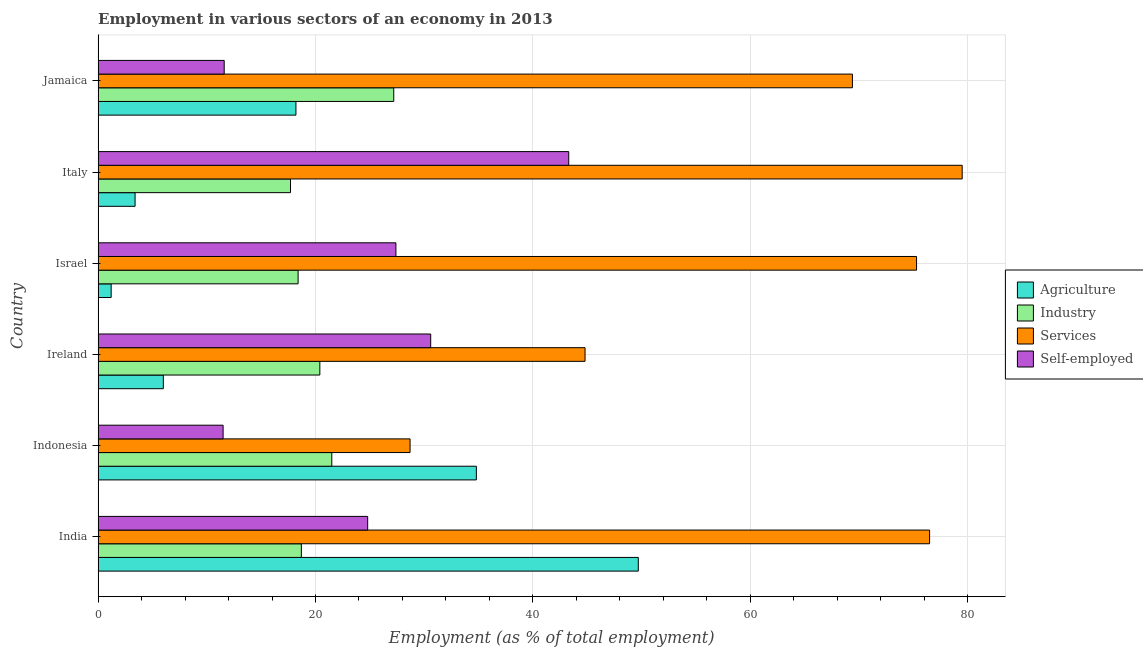How many different coloured bars are there?
Give a very brief answer. 4. How many groups of bars are there?
Your answer should be compact. 6. Are the number of bars per tick equal to the number of legend labels?
Provide a short and direct response. Yes. Are the number of bars on each tick of the Y-axis equal?
Give a very brief answer. Yes. How many bars are there on the 2nd tick from the bottom?
Provide a succinct answer. 4. What is the label of the 6th group of bars from the top?
Your answer should be compact. India. In how many cases, is the number of bars for a given country not equal to the number of legend labels?
Make the answer very short. 0. What is the percentage of workers in services in Jamaica?
Provide a succinct answer. 69.4. Across all countries, what is the maximum percentage of workers in services?
Your answer should be compact. 79.5. Across all countries, what is the minimum percentage of workers in industry?
Offer a very short reply. 17.7. What is the total percentage of self employed workers in the graph?
Provide a short and direct response. 149.2. What is the difference between the percentage of workers in agriculture in India and that in Ireland?
Provide a short and direct response. 43.7. What is the difference between the percentage of workers in industry in Jamaica and the percentage of workers in agriculture in Indonesia?
Make the answer very short. -7.6. What is the average percentage of workers in industry per country?
Provide a succinct answer. 20.65. In how many countries, is the percentage of workers in services greater than 76 %?
Your answer should be compact. 2. What is the ratio of the percentage of workers in services in Israel to that in Jamaica?
Offer a terse response. 1.08. Is the difference between the percentage of workers in services in India and Israel greater than the difference between the percentage of self employed workers in India and Israel?
Your response must be concise. Yes. What is the difference between the highest and the second highest percentage of workers in agriculture?
Keep it short and to the point. 14.9. What is the difference between the highest and the lowest percentage of workers in agriculture?
Your response must be concise. 48.5. In how many countries, is the percentage of self employed workers greater than the average percentage of self employed workers taken over all countries?
Provide a succinct answer. 3. Is the sum of the percentage of workers in services in Indonesia and Jamaica greater than the maximum percentage of workers in industry across all countries?
Keep it short and to the point. Yes. Is it the case that in every country, the sum of the percentage of workers in industry and percentage of workers in services is greater than the sum of percentage of self employed workers and percentage of workers in agriculture?
Your answer should be very brief. No. What does the 2nd bar from the top in Italy represents?
Provide a succinct answer. Services. What does the 2nd bar from the bottom in Jamaica represents?
Provide a succinct answer. Industry. Is it the case that in every country, the sum of the percentage of workers in agriculture and percentage of workers in industry is greater than the percentage of workers in services?
Your answer should be compact. No. How many bars are there?
Make the answer very short. 24. How many countries are there in the graph?
Offer a terse response. 6. What is the difference between two consecutive major ticks on the X-axis?
Ensure brevity in your answer.  20. How many legend labels are there?
Your answer should be very brief. 4. What is the title of the graph?
Offer a terse response. Employment in various sectors of an economy in 2013. Does "Ease of arranging shipments" appear as one of the legend labels in the graph?
Give a very brief answer. No. What is the label or title of the X-axis?
Ensure brevity in your answer.  Employment (as % of total employment). What is the Employment (as % of total employment) in Agriculture in India?
Keep it short and to the point. 49.7. What is the Employment (as % of total employment) of Industry in India?
Your answer should be compact. 18.7. What is the Employment (as % of total employment) of Services in India?
Keep it short and to the point. 76.5. What is the Employment (as % of total employment) in Self-employed in India?
Make the answer very short. 24.8. What is the Employment (as % of total employment) of Agriculture in Indonesia?
Provide a short and direct response. 34.8. What is the Employment (as % of total employment) in Services in Indonesia?
Give a very brief answer. 28.7. What is the Employment (as % of total employment) of Industry in Ireland?
Your answer should be compact. 20.4. What is the Employment (as % of total employment) of Services in Ireland?
Your answer should be very brief. 44.8. What is the Employment (as % of total employment) in Self-employed in Ireland?
Your answer should be compact. 30.6. What is the Employment (as % of total employment) in Agriculture in Israel?
Give a very brief answer. 1.2. What is the Employment (as % of total employment) in Industry in Israel?
Your answer should be compact. 18.4. What is the Employment (as % of total employment) in Services in Israel?
Make the answer very short. 75.3. What is the Employment (as % of total employment) in Self-employed in Israel?
Give a very brief answer. 27.4. What is the Employment (as % of total employment) in Agriculture in Italy?
Your answer should be very brief. 3.4. What is the Employment (as % of total employment) of Industry in Italy?
Ensure brevity in your answer.  17.7. What is the Employment (as % of total employment) in Services in Italy?
Offer a terse response. 79.5. What is the Employment (as % of total employment) in Self-employed in Italy?
Keep it short and to the point. 43.3. What is the Employment (as % of total employment) of Agriculture in Jamaica?
Ensure brevity in your answer.  18.2. What is the Employment (as % of total employment) of Industry in Jamaica?
Provide a succinct answer. 27.2. What is the Employment (as % of total employment) in Services in Jamaica?
Ensure brevity in your answer.  69.4. What is the Employment (as % of total employment) of Self-employed in Jamaica?
Your answer should be compact. 11.6. Across all countries, what is the maximum Employment (as % of total employment) of Agriculture?
Make the answer very short. 49.7. Across all countries, what is the maximum Employment (as % of total employment) in Industry?
Offer a very short reply. 27.2. Across all countries, what is the maximum Employment (as % of total employment) of Services?
Your answer should be compact. 79.5. Across all countries, what is the maximum Employment (as % of total employment) in Self-employed?
Offer a terse response. 43.3. Across all countries, what is the minimum Employment (as % of total employment) of Agriculture?
Provide a short and direct response. 1.2. Across all countries, what is the minimum Employment (as % of total employment) in Industry?
Give a very brief answer. 17.7. Across all countries, what is the minimum Employment (as % of total employment) in Services?
Your response must be concise. 28.7. What is the total Employment (as % of total employment) in Agriculture in the graph?
Keep it short and to the point. 113.3. What is the total Employment (as % of total employment) of Industry in the graph?
Your response must be concise. 123.9. What is the total Employment (as % of total employment) in Services in the graph?
Offer a very short reply. 374.2. What is the total Employment (as % of total employment) in Self-employed in the graph?
Give a very brief answer. 149.2. What is the difference between the Employment (as % of total employment) in Agriculture in India and that in Indonesia?
Your response must be concise. 14.9. What is the difference between the Employment (as % of total employment) of Services in India and that in Indonesia?
Offer a terse response. 47.8. What is the difference between the Employment (as % of total employment) in Agriculture in India and that in Ireland?
Your answer should be compact. 43.7. What is the difference between the Employment (as % of total employment) of Industry in India and that in Ireland?
Provide a short and direct response. -1.7. What is the difference between the Employment (as % of total employment) in Services in India and that in Ireland?
Your answer should be compact. 31.7. What is the difference between the Employment (as % of total employment) in Self-employed in India and that in Ireland?
Ensure brevity in your answer.  -5.8. What is the difference between the Employment (as % of total employment) of Agriculture in India and that in Israel?
Your response must be concise. 48.5. What is the difference between the Employment (as % of total employment) in Agriculture in India and that in Italy?
Offer a very short reply. 46.3. What is the difference between the Employment (as % of total employment) of Self-employed in India and that in Italy?
Ensure brevity in your answer.  -18.5. What is the difference between the Employment (as % of total employment) in Agriculture in India and that in Jamaica?
Offer a terse response. 31.5. What is the difference between the Employment (as % of total employment) of Services in India and that in Jamaica?
Provide a short and direct response. 7.1. What is the difference between the Employment (as % of total employment) in Self-employed in India and that in Jamaica?
Offer a terse response. 13.2. What is the difference between the Employment (as % of total employment) in Agriculture in Indonesia and that in Ireland?
Provide a short and direct response. 28.8. What is the difference between the Employment (as % of total employment) of Industry in Indonesia and that in Ireland?
Keep it short and to the point. 1.1. What is the difference between the Employment (as % of total employment) of Services in Indonesia and that in Ireland?
Ensure brevity in your answer.  -16.1. What is the difference between the Employment (as % of total employment) in Self-employed in Indonesia and that in Ireland?
Your response must be concise. -19.1. What is the difference between the Employment (as % of total employment) of Agriculture in Indonesia and that in Israel?
Your answer should be compact. 33.6. What is the difference between the Employment (as % of total employment) of Industry in Indonesia and that in Israel?
Your response must be concise. 3.1. What is the difference between the Employment (as % of total employment) of Services in Indonesia and that in Israel?
Offer a very short reply. -46.6. What is the difference between the Employment (as % of total employment) in Self-employed in Indonesia and that in Israel?
Give a very brief answer. -15.9. What is the difference between the Employment (as % of total employment) in Agriculture in Indonesia and that in Italy?
Offer a terse response. 31.4. What is the difference between the Employment (as % of total employment) in Services in Indonesia and that in Italy?
Offer a terse response. -50.8. What is the difference between the Employment (as % of total employment) of Self-employed in Indonesia and that in Italy?
Offer a terse response. -31.8. What is the difference between the Employment (as % of total employment) in Agriculture in Indonesia and that in Jamaica?
Keep it short and to the point. 16.6. What is the difference between the Employment (as % of total employment) of Services in Indonesia and that in Jamaica?
Your answer should be very brief. -40.7. What is the difference between the Employment (as % of total employment) in Agriculture in Ireland and that in Israel?
Ensure brevity in your answer.  4.8. What is the difference between the Employment (as % of total employment) in Industry in Ireland and that in Israel?
Your answer should be compact. 2. What is the difference between the Employment (as % of total employment) of Services in Ireland and that in Israel?
Offer a very short reply. -30.5. What is the difference between the Employment (as % of total employment) of Self-employed in Ireland and that in Israel?
Offer a terse response. 3.2. What is the difference between the Employment (as % of total employment) in Agriculture in Ireland and that in Italy?
Your answer should be compact. 2.6. What is the difference between the Employment (as % of total employment) in Industry in Ireland and that in Italy?
Offer a very short reply. 2.7. What is the difference between the Employment (as % of total employment) in Services in Ireland and that in Italy?
Provide a short and direct response. -34.7. What is the difference between the Employment (as % of total employment) in Self-employed in Ireland and that in Italy?
Provide a short and direct response. -12.7. What is the difference between the Employment (as % of total employment) in Agriculture in Ireland and that in Jamaica?
Provide a short and direct response. -12.2. What is the difference between the Employment (as % of total employment) of Industry in Ireland and that in Jamaica?
Your response must be concise. -6.8. What is the difference between the Employment (as % of total employment) in Services in Ireland and that in Jamaica?
Your answer should be compact. -24.6. What is the difference between the Employment (as % of total employment) of Agriculture in Israel and that in Italy?
Make the answer very short. -2.2. What is the difference between the Employment (as % of total employment) of Industry in Israel and that in Italy?
Provide a short and direct response. 0.7. What is the difference between the Employment (as % of total employment) of Self-employed in Israel and that in Italy?
Your response must be concise. -15.9. What is the difference between the Employment (as % of total employment) in Agriculture in Israel and that in Jamaica?
Your answer should be compact. -17. What is the difference between the Employment (as % of total employment) of Industry in Israel and that in Jamaica?
Your answer should be very brief. -8.8. What is the difference between the Employment (as % of total employment) in Services in Israel and that in Jamaica?
Provide a succinct answer. 5.9. What is the difference between the Employment (as % of total employment) of Self-employed in Israel and that in Jamaica?
Offer a terse response. 15.8. What is the difference between the Employment (as % of total employment) in Agriculture in Italy and that in Jamaica?
Make the answer very short. -14.8. What is the difference between the Employment (as % of total employment) in Industry in Italy and that in Jamaica?
Provide a succinct answer. -9.5. What is the difference between the Employment (as % of total employment) of Services in Italy and that in Jamaica?
Give a very brief answer. 10.1. What is the difference between the Employment (as % of total employment) in Self-employed in Italy and that in Jamaica?
Keep it short and to the point. 31.7. What is the difference between the Employment (as % of total employment) in Agriculture in India and the Employment (as % of total employment) in Industry in Indonesia?
Your answer should be very brief. 28.2. What is the difference between the Employment (as % of total employment) in Agriculture in India and the Employment (as % of total employment) in Services in Indonesia?
Provide a short and direct response. 21. What is the difference between the Employment (as % of total employment) of Agriculture in India and the Employment (as % of total employment) of Self-employed in Indonesia?
Keep it short and to the point. 38.2. What is the difference between the Employment (as % of total employment) of Industry in India and the Employment (as % of total employment) of Self-employed in Indonesia?
Your answer should be very brief. 7.2. What is the difference between the Employment (as % of total employment) in Agriculture in India and the Employment (as % of total employment) in Industry in Ireland?
Your answer should be compact. 29.3. What is the difference between the Employment (as % of total employment) in Agriculture in India and the Employment (as % of total employment) in Services in Ireland?
Offer a very short reply. 4.9. What is the difference between the Employment (as % of total employment) in Industry in India and the Employment (as % of total employment) in Services in Ireland?
Offer a very short reply. -26.1. What is the difference between the Employment (as % of total employment) of Industry in India and the Employment (as % of total employment) of Self-employed in Ireland?
Your response must be concise. -11.9. What is the difference between the Employment (as % of total employment) of Services in India and the Employment (as % of total employment) of Self-employed in Ireland?
Provide a succinct answer. 45.9. What is the difference between the Employment (as % of total employment) in Agriculture in India and the Employment (as % of total employment) in Industry in Israel?
Ensure brevity in your answer.  31.3. What is the difference between the Employment (as % of total employment) in Agriculture in India and the Employment (as % of total employment) in Services in Israel?
Ensure brevity in your answer.  -25.6. What is the difference between the Employment (as % of total employment) in Agriculture in India and the Employment (as % of total employment) in Self-employed in Israel?
Your answer should be compact. 22.3. What is the difference between the Employment (as % of total employment) of Industry in India and the Employment (as % of total employment) of Services in Israel?
Provide a short and direct response. -56.6. What is the difference between the Employment (as % of total employment) in Industry in India and the Employment (as % of total employment) in Self-employed in Israel?
Make the answer very short. -8.7. What is the difference between the Employment (as % of total employment) of Services in India and the Employment (as % of total employment) of Self-employed in Israel?
Provide a short and direct response. 49.1. What is the difference between the Employment (as % of total employment) of Agriculture in India and the Employment (as % of total employment) of Industry in Italy?
Give a very brief answer. 32. What is the difference between the Employment (as % of total employment) of Agriculture in India and the Employment (as % of total employment) of Services in Italy?
Your response must be concise. -29.8. What is the difference between the Employment (as % of total employment) in Agriculture in India and the Employment (as % of total employment) in Self-employed in Italy?
Offer a very short reply. 6.4. What is the difference between the Employment (as % of total employment) in Industry in India and the Employment (as % of total employment) in Services in Italy?
Provide a succinct answer. -60.8. What is the difference between the Employment (as % of total employment) of Industry in India and the Employment (as % of total employment) of Self-employed in Italy?
Provide a succinct answer. -24.6. What is the difference between the Employment (as % of total employment) of Services in India and the Employment (as % of total employment) of Self-employed in Italy?
Your answer should be very brief. 33.2. What is the difference between the Employment (as % of total employment) in Agriculture in India and the Employment (as % of total employment) in Services in Jamaica?
Offer a very short reply. -19.7. What is the difference between the Employment (as % of total employment) in Agriculture in India and the Employment (as % of total employment) in Self-employed in Jamaica?
Offer a very short reply. 38.1. What is the difference between the Employment (as % of total employment) in Industry in India and the Employment (as % of total employment) in Services in Jamaica?
Give a very brief answer. -50.7. What is the difference between the Employment (as % of total employment) in Services in India and the Employment (as % of total employment) in Self-employed in Jamaica?
Offer a very short reply. 64.9. What is the difference between the Employment (as % of total employment) in Agriculture in Indonesia and the Employment (as % of total employment) in Services in Ireland?
Offer a terse response. -10. What is the difference between the Employment (as % of total employment) in Agriculture in Indonesia and the Employment (as % of total employment) in Self-employed in Ireland?
Offer a terse response. 4.2. What is the difference between the Employment (as % of total employment) in Industry in Indonesia and the Employment (as % of total employment) in Services in Ireland?
Your response must be concise. -23.3. What is the difference between the Employment (as % of total employment) in Agriculture in Indonesia and the Employment (as % of total employment) in Services in Israel?
Provide a succinct answer. -40.5. What is the difference between the Employment (as % of total employment) of Agriculture in Indonesia and the Employment (as % of total employment) of Self-employed in Israel?
Your answer should be compact. 7.4. What is the difference between the Employment (as % of total employment) of Industry in Indonesia and the Employment (as % of total employment) of Services in Israel?
Your answer should be very brief. -53.8. What is the difference between the Employment (as % of total employment) of Industry in Indonesia and the Employment (as % of total employment) of Self-employed in Israel?
Your answer should be very brief. -5.9. What is the difference between the Employment (as % of total employment) in Services in Indonesia and the Employment (as % of total employment) in Self-employed in Israel?
Provide a short and direct response. 1.3. What is the difference between the Employment (as % of total employment) in Agriculture in Indonesia and the Employment (as % of total employment) in Industry in Italy?
Offer a terse response. 17.1. What is the difference between the Employment (as % of total employment) of Agriculture in Indonesia and the Employment (as % of total employment) of Services in Italy?
Provide a succinct answer. -44.7. What is the difference between the Employment (as % of total employment) of Agriculture in Indonesia and the Employment (as % of total employment) of Self-employed in Italy?
Provide a short and direct response. -8.5. What is the difference between the Employment (as % of total employment) in Industry in Indonesia and the Employment (as % of total employment) in Services in Italy?
Ensure brevity in your answer.  -58. What is the difference between the Employment (as % of total employment) of Industry in Indonesia and the Employment (as % of total employment) of Self-employed in Italy?
Give a very brief answer. -21.8. What is the difference between the Employment (as % of total employment) in Services in Indonesia and the Employment (as % of total employment) in Self-employed in Italy?
Keep it short and to the point. -14.6. What is the difference between the Employment (as % of total employment) in Agriculture in Indonesia and the Employment (as % of total employment) in Industry in Jamaica?
Provide a succinct answer. 7.6. What is the difference between the Employment (as % of total employment) in Agriculture in Indonesia and the Employment (as % of total employment) in Services in Jamaica?
Offer a terse response. -34.6. What is the difference between the Employment (as % of total employment) in Agriculture in Indonesia and the Employment (as % of total employment) in Self-employed in Jamaica?
Offer a very short reply. 23.2. What is the difference between the Employment (as % of total employment) of Industry in Indonesia and the Employment (as % of total employment) of Services in Jamaica?
Keep it short and to the point. -47.9. What is the difference between the Employment (as % of total employment) in Agriculture in Ireland and the Employment (as % of total employment) in Services in Israel?
Give a very brief answer. -69.3. What is the difference between the Employment (as % of total employment) of Agriculture in Ireland and the Employment (as % of total employment) of Self-employed in Israel?
Your response must be concise. -21.4. What is the difference between the Employment (as % of total employment) of Industry in Ireland and the Employment (as % of total employment) of Services in Israel?
Your answer should be compact. -54.9. What is the difference between the Employment (as % of total employment) of Industry in Ireland and the Employment (as % of total employment) of Self-employed in Israel?
Provide a short and direct response. -7. What is the difference between the Employment (as % of total employment) of Agriculture in Ireland and the Employment (as % of total employment) of Services in Italy?
Your answer should be very brief. -73.5. What is the difference between the Employment (as % of total employment) of Agriculture in Ireland and the Employment (as % of total employment) of Self-employed in Italy?
Ensure brevity in your answer.  -37.3. What is the difference between the Employment (as % of total employment) of Industry in Ireland and the Employment (as % of total employment) of Services in Italy?
Keep it short and to the point. -59.1. What is the difference between the Employment (as % of total employment) in Industry in Ireland and the Employment (as % of total employment) in Self-employed in Italy?
Offer a very short reply. -22.9. What is the difference between the Employment (as % of total employment) in Services in Ireland and the Employment (as % of total employment) in Self-employed in Italy?
Your answer should be very brief. 1.5. What is the difference between the Employment (as % of total employment) of Agriculture in Ireland and the Employment (as % of total employment) of Industry in Jamaica?
Provide a short and direct response. -21.2. What is the difference between the Employment (as % of total employment) of Agriculture in Ireland and the Employment (as % of total employment) of Services in Jamaica?
Offer a very short reply. -63.4. What is the difference between the Employment (as % of total employment) of Industry in Ireland and the Employment (as % of total employment) of Services in Jamaica?
Your answer should be compact. -49. What is the difference between the Employment (as % of total employment) in Industry in Ireland and the Employment (as % of total employment) in Self-employed in Jamaica?
Your answer should be compact. 8.8. What is the difference between the Employment (as % of total employment) in Services in Ireland and the Employment (as % of total employment) in Self-employed in Jamaica?
Make the answer very short. 33.2. What is the difference between the Employment (as % of total employment) of Agriculture in Israel and the Employment (as % of total employment) of Industry in Italy?
Provide a short and direct response. -16.5. What is the difference between the Employment (as % of total employment) of Agriculture in Israel and the Employment (as % of total employment) of Services in Italy?
Keep it short and to the point. -78.3. What is the difference between the Employment (as % of total employment) in Agriculture in Israel and the Employment (as % of total employment) in Self-employed in Italy?
Provide a succinct answer. -42.1. What is the difference between the Employment (as % of total employment) of Industry in Israel and the Employment (as % of total employment) of Services in Italy?
Offer a terse response. -61.1. What is the difference between the Employment (as % of total employment) in Industry in Israel and the Employment (as % of total employment) in Self-employed in Italy?
Ensure brevity in your answer.  -24.9. What is the difference between the Employment (as % of total employment) in Services in Israel and the Employment (as % of total employment) in Self-employed in Italy?
Make the answer very short. 32. What is the difference between the Employment (as % of total employment) of Agriculture in Israel and the Employment (as % of total employment) of Services in Jamaica?
Make the answer very short. -68.2. What is the difference between the Employment (as % of total employment) in Industry in Israel and the Employment (as % of total employment) in Services in Jamaica?
Provide a succinct answer. -51. What is the difference between the Employment (as % of total employment) in Services in Israel and the Employment (as % of total employment) in Self-employed in Jamaica?
Your response must be concise. 63.7. What is the difference between the Employment (as % of total employment) of Agriculture in Italy and the Employment (as % of total employment) of Industry in Jamaica?
Your answer should be compact. -23.8. What is the difference between the Employment (as % of total employment) of Agriculture in Italy and the Employment (as % of total employment) of Services in Jamaica?
Give a very brief answer. -66. What is the difference between the Employment (as % of total employment) in Agriculture in Italy and the Employment (as % of total employment) in Self-employed in Jamaica?
Your answer should be very brief. -8.2. What is the difference between the Employment (as % of total employment) in Industry in Italy and the Employment (as % of total employment) in Services in Jamaica?
Ensure brevity in your answer.  -51.7. What is the difference between the Employment (as % of total employment) of Industry in Italy and the Employment (as % of total employment) of Self-employed in Jamaica?
Provide a succinct answer. 6.1. What is the difference between the Employment (as % of total employment) in Services in Italy and the Employment (as % of total employment) in Self-employed in Jamaica?
Make the answer very short. 67.9. What is the average Employment (as % of total employment) in Agriculture per country?
Ensure brevity in your answer.  18.88. What is the average Employment (as % of total employment) in Industry per country?
Keep it short and to the point. 20.65. What is the average Employment (as % of total employment) of Services per country?
Your answer should be compact. 62.37. What is the average Employment (as % of total employment) in Self-employed per country?
Provide a succinct answer. 24.87. What is the difference between the Employment (as % of total employment) in Agriculture and Employment (as % of total employment) in Services in India?
Offer a terse response. -26.8. What is the difference between the Employment (as % of total employment) of Agriculture and Employment (as % of total employment) of Self-employed in India?
Provide a short and direct response. 24.9. What is the difference between the Employment (as % of total employment) of Industry and Employment (as % of total employment) of Services in India?
Your answer should be compact. -57.8. What is the difference between the Employment (as % of total employment) in Services and Employment (as % of total employment) in Self-employed in India?
Keep it short and to the point. 51.7. What is the difference between the Employment (as % of total employment) of Agriculture and Employment (as % of total employment) of Industry in Indonesia?
Your answer should be very brief. 13.3. What is the difference between the Employment (as % of total employment) in Agriculture and Employment (as % of total employment) in Services in Indonesia?
Your response must be concise. 6.1. What is the difference between the Employment (as % of total employment) of Agriculture and Employment (as % of total employment) of Self-employed in Indonesia?
Your response must be concise. 23.3. What is the difference between the Employment (as % of total employment) of Industry and Employment (as % of total employment) of Services in Indonesia?
Offer a terse response. -7.2. What is the difference between the Employment (as % of total employment) of Services and Employment (as % of total employment) of Self-employed in Indonesia?
Provide a short and direct response. 17.2. What is the difference between the Employment (as % of total employment) in Agriculture and Employment (as % of total employment) in Industry in Ireland?
Make the answer very short. -14.4. What is the difference between the Employment (as % of total employment) in Agriculture and Employment (as % of total employment) in Services in Ireland?
Keep it short and to the point. -38.8. What is the difference between the Employment (as % of total employment) in Agriculture and Employment (as % of total employment) in Self-employed in Ireland?
Keep it short and to the point. -24.6. What is the difference between the Employment (as % of total employment) of Industry and Employment (as % of total employment) of Services in Ireland?
Offer a very short reply. -24.4. What is the difference between the Employment (as % of total employment) of Industry and Employment (as % of total employment) of Self-employed in Ireland?
Your response must be concise. -10.2. What is the difference between the Employment (as % of total employment) in Agriculture and Employment (as % of total employment) in Industry in Israel?
Your response must be concise. -17.2. What is the difference between the Employment (as % of total employment) of Agriculture and Employment (as % of total employment) of Services in Israel?
Your response must be concise. -74.1. What is the difference between the Employment (as % of total employment) in Agriculture and Employment (as % of total employment) in Self-employed in Israel?
Your response must be concise. -26.2. What is the difference between the Employment (as % of total employment) of Industry and Employment (as % of total employment) of Services in Israel?
Your answer should be compact. -56.9. What is the difference between the Employment (as % of total employment) of Industry and Employment (as % of total employment) of Self-employed in Israel?
Offer a terse response. -9. What is the difference between the Employment (as % of total employment) of Services and Employment (as % of total employment) of Self-employed in Israel?
Provide a short and direct response. 47.9. What is the difference between the Employment (as % of total employment) of Agriculture and Employment (as % of total employment) of Industry in Italy?
Provide a short and direct response. -14.3. What is the difference between the Employment (as % of total employment) of Agriculture and Employment (as % of total employment) of Services in Italy?
Offer a very short reply. -76.1. What is the difference between the Employment (as % of total employment) of Agriculture and Employment (as % of total employment) of Self-employed in Italy?
Offer a very short reply. -39.9. What is the difference between the Employment (as % of total employment) of Industry and Employment (as % of total employment) of Services in Italy?
Ensure brevity in your answer.  -61.8. What is the difference between the Employment (as % of total employment) of Industry and Employment (as % of total employment) of Self-employed in Italy?
Ensure brevity in your answer.  -25.6. What is the difference between the Employment (as % of total employment) of Services and Employment (as % of total employment) of Self-employed in Italy?
Keep it short and to the point. 36.2. What is the difference between the Employment (as % of total employment) in Agriculture and Employment (as % of total employment) in Services in Jamaica?
Give a very brief answer. -51.2. What is the difference between the Employment (as % of total employment) in Industry and Employment (as % of total employment) in Services in Jamaica?
Offer a very short reply. -42.2. What is the difference between the Employment (as % of total employment) in Services and Employment (as % of total employment) in Self-employed in Jamaica?
Your answer should be very brief. 57.8. What is the ratio of the Employment (as % of total employment) of Agriculture in India to that in Indonesia?
Make the answer very short. 1.43. What is the ratio of the Employment (as % of total employment) of Industry in India to that in Indonesia?
Your answer should be very brief. 0.87. What is the ratio of the Employment (as % of total employment) in Services in India to that in Indonesia?
Provide a succinct answer. 2.67. What is the ratio of the Employment (as % of total employment) of Self-employed in India to that in Indonesia?
Provide a succinct answer. 2.16. What is the ratio of the Employment (as % of total employment) of Agriculture in India to that in Ireland?
Your response must be concise. 8.28. What is the ratio of the Employment (as % of total employment) in Services in India to that in Ireland?
Keep it short and to the point. 1.71. What is the ratio of the Employment (as % of total employment) of Self-employed in India to that in Ireland?
Your answer should be compact. 0.81. What is the ratio of the Employment (as % of total employment) in Agriculture in India to that in Israel?
Offer a very short reply. 41.42. What is the ratio of the Employment (as % of total employment) of Industry in India to that in Israel?
Give a very brief answer. 1.02. What is the ratio of the Employment (as % of total employment) of Services in India to that in Israel?
Offer a very short reply. 1.02. What is the ratio of the Employment (as % of total employment) of Self-employed in India to that in Israel?
Your response must be concise. 0.91. What is the ratio of the Employment (as % of total employment) of Agriculture in India to that in Italy?
Your answer should be very brief. 14.62. What is the ratio of the Employment (as % of total employment) in Industry in India to that in Italy?
Offer a very short reply. 1.06. What is the ratio of the Employment (as % of total employment) of Services in India to that in Italy?
Provide a succinct answer. 0.96. What is the ratio of the Employment (as % of total employment) in Self-employed in India to that in Italy?
Your response must be concise. 0.57. What is the ratio of the Employment (as % of total employment) in Agriculture in India to that in Jamaica?
Give a very brief answer. 2.73. What is the ratio of the Employment (as % of total employment) of Industry in India to that in Jamaica?
Your response must be concise. 0.69. What is the ratio of the Employment (as % of total employment) in Services in India to that in Jamaica?
Keep it short and to the point. 1.1. What is the ratio of the Employment (as % of total employment) in Self-employed in India to that in Jamaica?
Your response must be concise. 2.14. What is the ratio of the Employment (as % of total employment) in Industry in Indonesia to that in Ireland?
Ensure brevity in your answer.  1.05. What is the ratio of the Employment (as % of total employment) of Services in Indonesia to that in Ireland?
Provide a short and direct response. 0.64. What is the ratio of the Employment (as % of total employment) in Self-employed in Indonesia to that in Ireland?
Offer a very short reply. 0.38. What is the ratio of the Employment (as % of total employment) in Industry in Indonesia to that in Israel?
Make the answer very short. 1.17. What is the ratio of the Employment (as % of total employment) of Services in Indonesia to that in Israel?
Make the answer very short. 0.38. What is the ratio of the Employment (as % of total employment) in Self-employed in Indonesia to that in Israel?
Give a very brief answer. 0.42. What is the ratio of the Employment (as % of total employment) in Agriculture in Indonesia to that in Italy?
Provide a short and direct response. 10.24. What is the ratio of the Employment (as % of total employment) in Industry in Indonesia to that in Italy?
Make the answer very short. 1.21. What is the ratio of the Employment (as % of total employment) in Services in Indonesia to that in Italy?
Your answer should be compact. 0.36. What is the ratio of the Employment (as % of total employment) of Self-employed in Indonesia to that in Italy?
Give a very brief answer. 0.27. What is the ratio of the Employment (as % of total employment) of Agriculture in Indonesia to that in Jamaica?
Your answer should be very brief. 1.91. What is the ratio of the Employment (as % of total employment) in Industry in Indonesia to that in Jamaica?
Offer a very short reply. 0.79. What is the ratio of the Employment (as % of total employment) of Services in Indonesia to that in Jamaica?
Your answer should be very brief. 0.41. What is the ratio of the Employment (as % of total employment) of Self-employed in Indonesia to that in Jamaica?
Keep it short and to the point. 0.99. What is the ratio of the Employment (as % of total employment) in Agriculture in Ireland to that in Israel?
Offer a very short reply. 5. What is the ratio of the Employment (as % of total employment) in Industry in Ireland to that in Israel?
Offer a very short reply. 1.11. What is the ratio of the Employment (as % of total employment) in Services in Ireland to that in Israel?
Offer a terse response. 0.59. What is the ratio of the Employment (as % of total employment) in Self-employed in Ireland to that in Israel?
Provide a short and direct response. 1.12. What is the ratio of the Employment (as % of total employment) in Agriculture in Ireland to that in Italy?
Your answer should be very brief. 1.76. What is the ratio of the Employment (as % of total employment) in Industry in Ireland to that in Italy?
Offer a very short reply. 1.15. What is the ratio of the Employment (as % of total employment) in Services in Ireland to that in Italy?
Provide a succinct answer. 0.56. What is the ratio of the Employment (as % of total employment) in Self-employed in Ireland to that in Italy?
Make the answer very short. 0.71. What is the ratio of the Employment (as % of total employment) of Agriculture in Ireland to that in Jamaica?
Your answer should be compact. 0.33. What is the ratio of the Employment (as % of total employment) in Industry in Ireland to that in Jamaica?
Your answer should be very brief. 0.75. What is the ratio of the Employment (as % of total employment) of Services in Ireland to that in Jamaica?
Make the answer very short. 0.65. What is the ratio of the Employment (as % of total employment) in Self-employed in Ireland to that in Jamaica?
Ensure brevity in your answer.  2.64. What is the ratio of the Employment (as % of total employment) in Agriculture in Israel to that in Italy?
Ensure brevity in your answer.  0.35. What is the ratio of the Employment (as % of total employment) of Industry in Israel to that in Italy?
Provide a short and direct response. 1.04. What is the ratio of the Employment (as % of total employment) in Services in Israel to that in Italy?
Ensure brevity in your answer.  0.95. What is the ratio of the Employment (as % of total employment) of Self-employed in Israel to that in Italy?
Offer a terse response. 0.63. What is the ratio of the Employment (as % of total employment) of Agriculture in Israel to that in Jamaica?
Ensure brevity in your answer.  0.07. What is the ratio of the Employment (as % of total employment) in Industry in Israel to that in Jamaica?
Provide a succinct answer. 0.68. What is the ratio of the Employment (as % of total employment) in Services in Israel to that in Jamaica?
Provide a succinct answer. 1.08. What is the ratio of the Employment (as % of total employment) of Self-employed in Israel to that in Jamaica?
Your answer should be very brief. 2.36. What is the ratio of the Employment (as % of total employment) of Agriculture in Italy to that in Jamaica?
Offer a terse response. 0.19. What is the ratio of the Employment (as % of total employment) of Industry in Italy to that in Jamaica?
Ensure brevity in your answer.  0.65. What is the ratio of the Employment (as % of total employment) in Services in Italy to that in Jamaica?
Your response must be concise. 1.15. What is the ratio of the Employment (as % of total employment) in Self-employed in Italy to that in Jamaica?
Provide a succinct answer. 3.73. What is the difference between the highest and the second highest Employment (as % of total employment) of Agriculture?
Offer a terse response. 14.9. What is the difference between the highest and the lowest Employment (as % of total employment) of Agriculture?
Keep it short and to the point. 48.5. What is the difference between the highest and the lowest Employment (as % of total employment) in Services?
Ensure brevity in your answer.  50.8. What is the difference between the highest and the lowest Employment (as % of total employment) of Self-employed?
Your answer should be compact. 31.8. 